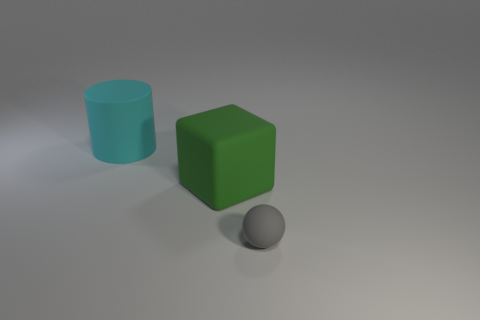Add 3 big green blocks. How many objects exist? 6 Subtract all cubes. How many objects are left? 2 Subtract 0 purple balls. How many objects are left? 3 Subtract all big cyan cylinders. Subtract all big rubber cubes. How many objects are left? 1 Add 2 tiny gray matte objects. How many tiny gray matte objects are left? 3 Add 2 big blocks. How many big blocks exist? 3 